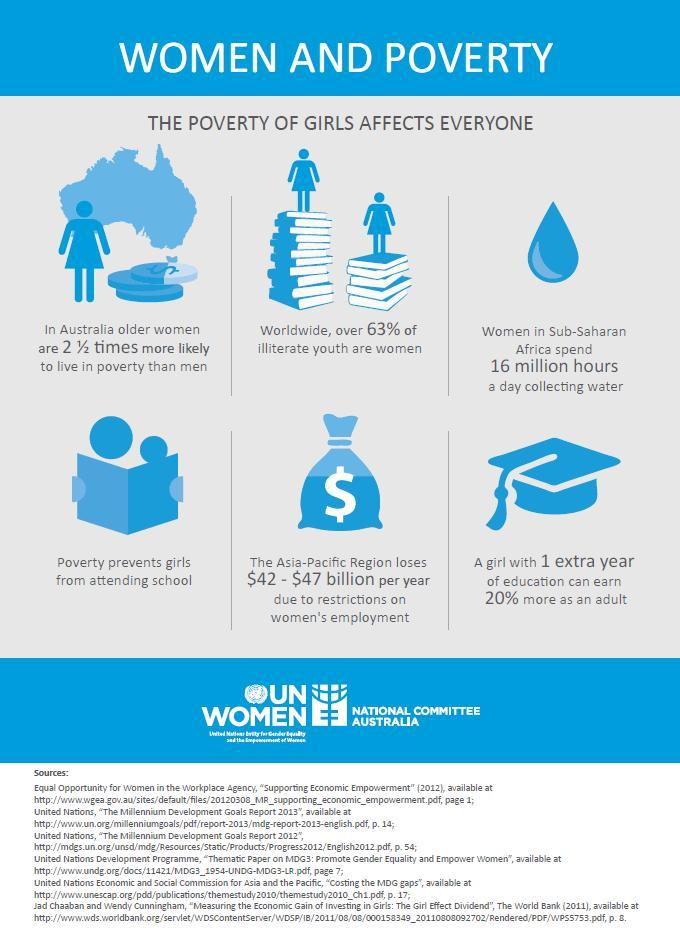what is the illiteracy rate in women amount youth
Answer the question with a short phrase. 63% what is the benefit of 1 extra year of girl education can earn 20% more as an adult how much revenue can be saved per year by removing restrictions on women's employment $42 - $47 billion 